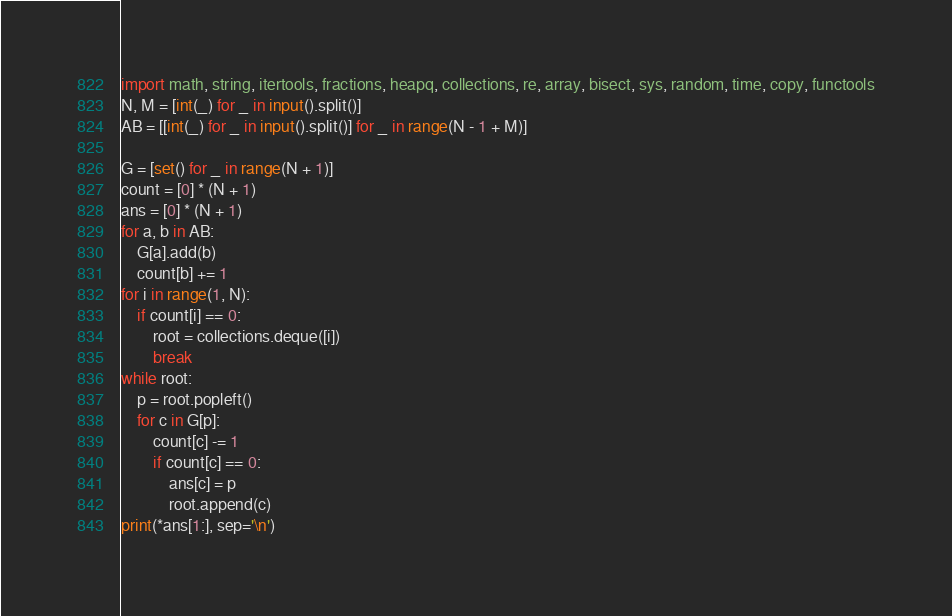Convert code to text. <code><loc_0><loc_0><loc_500><loc_500><_Python_>import math, string, itertools, fractions, heapq, collections, re, array, bisect, sys, random, time, copy, functools
N, M = [int(_) for _ in input().split()]
AB = [[int(_) for _ in input().split()] for _ in range(N - 1 + M)]

G = [set() for _ in range(N + 1)]
count = [0] * (N + 1)
ans = [0] * (N + 1)
for a, b in AB:
    G[a].add(b)
    count[b] += 1
for i in range(1, N):
    if count[i] == 0:
        root = collections.deque([i])
        break
while root:
    p = root.popleft()
    for c in G[p]:
        count[c] -= 1
        if count[c] == 0:
            ans[c] = p
            root.append(c)
print(*ans[1:], sep='\n')
</code> 